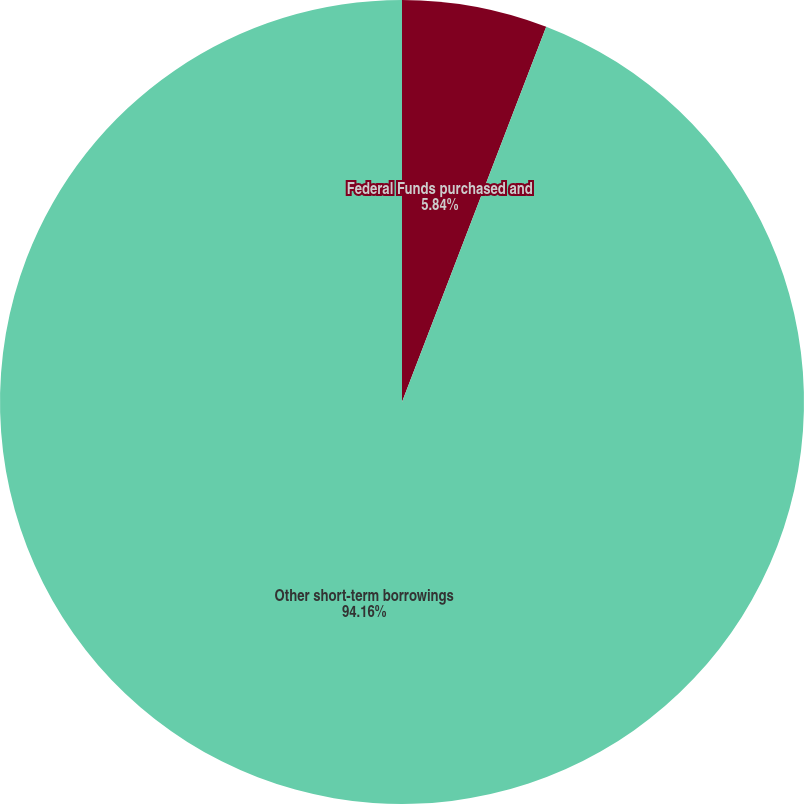Convert chart to OTSL. <chart><loc_0><loc_0><loc_500><loc_500><pie_chart><fcel>Federal Funds purchased and<fcel>Other short-term borrowings<nl><fcel>5.84%<fcel>94.16%<nl></chart> 